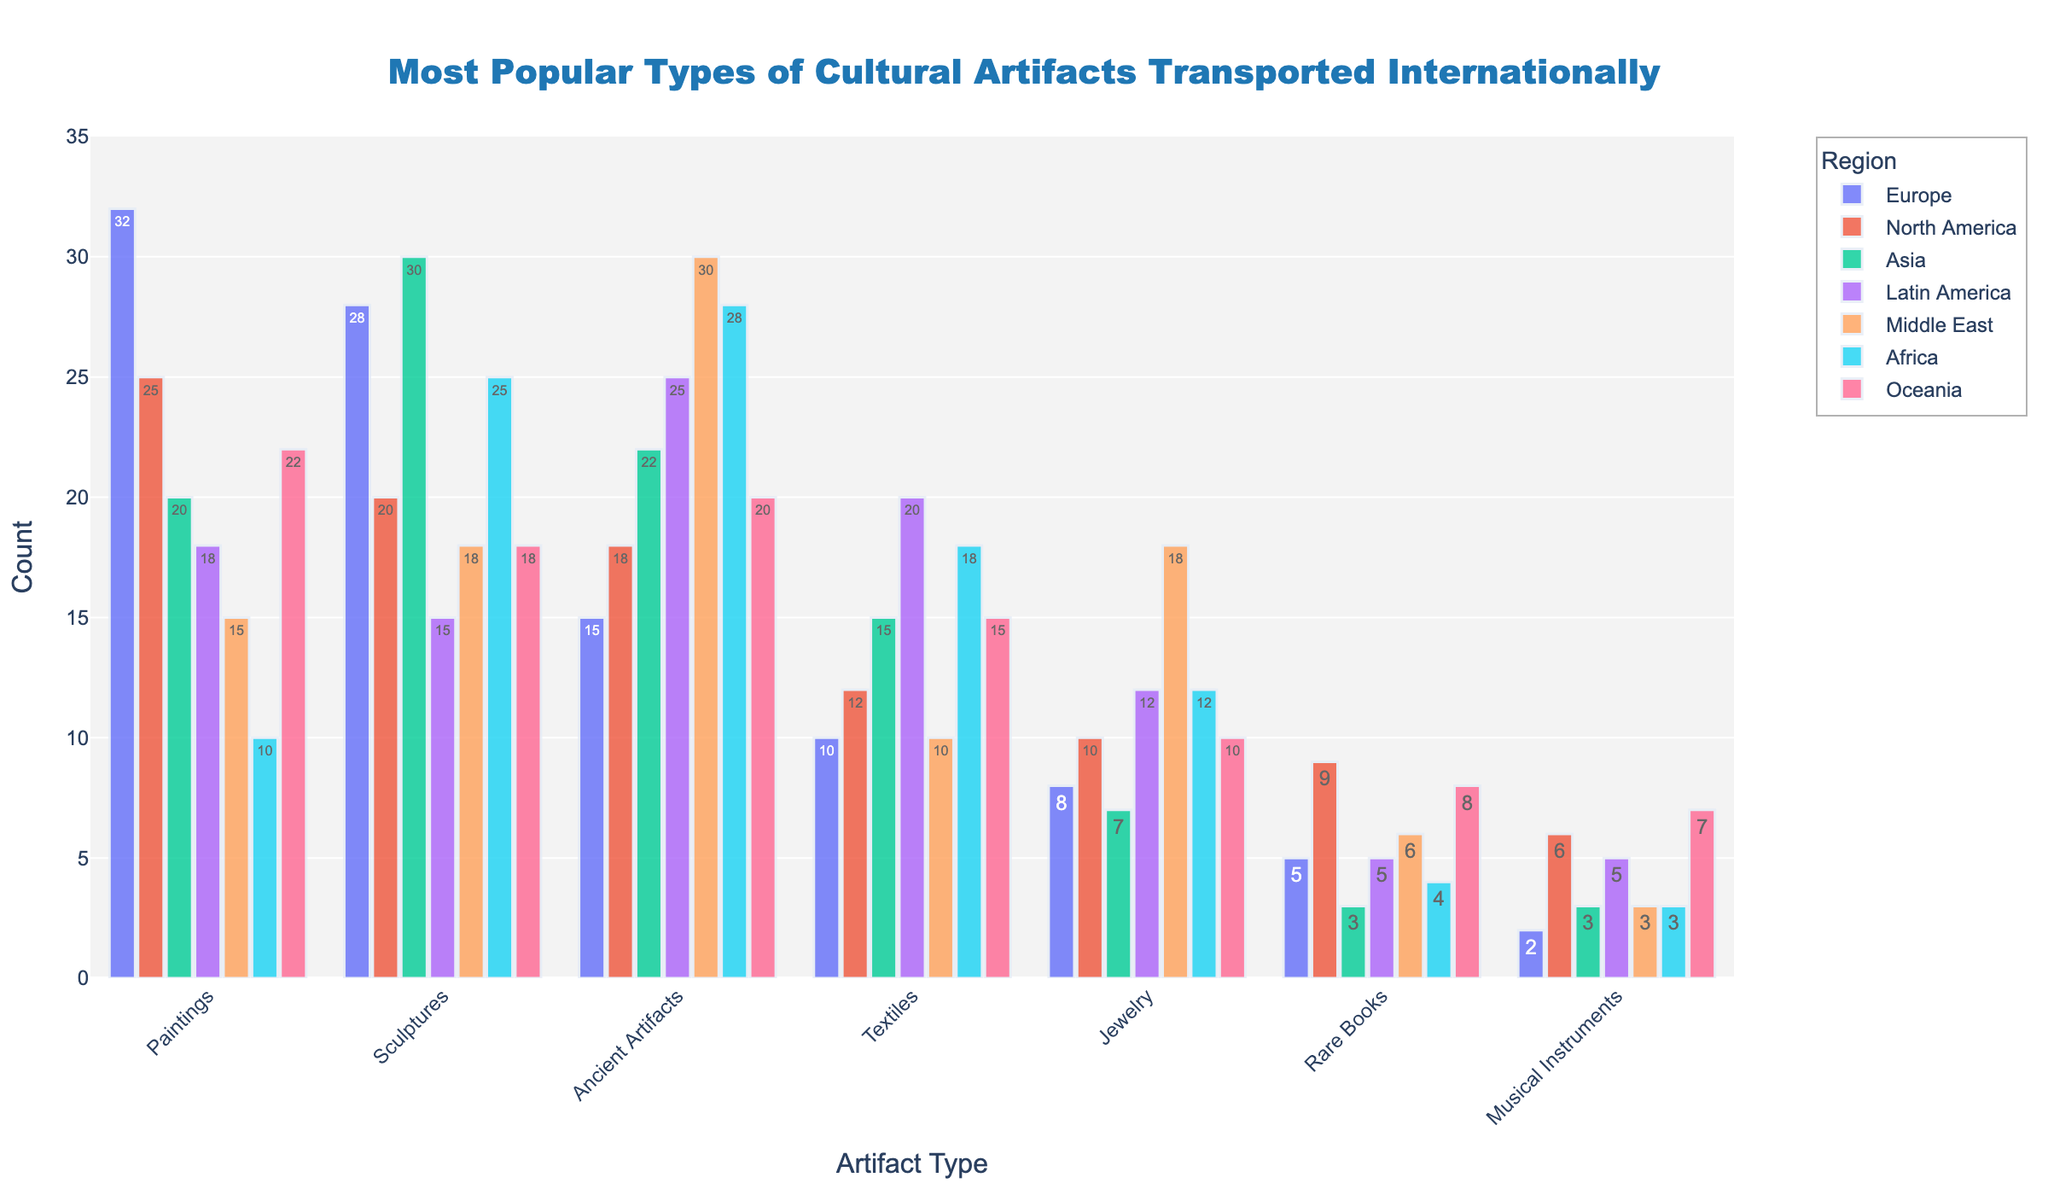Which region has the highest number of sculptures transported? The bar representing Asia for Sculptures is the tallest among all regions.
Answer: Asia What is the difference in the number of paintings transported between Europe and North America? Europe transported 32 paintings, and North America transported 25. The difference is 32 - 25.
Answer: 7 Which artifact type is most popular in the Middle East? The tallest bar for the Middle East is Ancient Artifacts.
Answer: Ancient Artifacts How many total types of artifacts were transported from Africa? Adding the counts for Africa: 10 (Paintings) + 25 (Sculptures) + 28 (Ancient Artifacts) + 18 (Textiles) + 12 (Jewelry) + 4 (Rare Books) + 3 (Musical Instruments) = 100.
Answer: 100 Which region has the least number of musical instruments transported? Europe has the shortest bar for Musical Instruments with 2.
Answer: Europe Is the number of rare books transported from Oceania greater than from the Middle East? Oceania transported 8 rare books, while the Middle East transported 6. 8 is greater than 6.
Answer: Yes How many more ancient artifacts does Asia transport compared to Europe? Asia transported 22 Ancient Artifacts, and Europe transported 15. The difference is 22 - 15.
Answer: 7 What is the average number of transported textiles across all regions? To find the average, sum the counts for Textiles: 10 (Europe) + 12 (North America) + 15 (Asia) + 20 (Latin America) + 10 (Middle East) + 18 (Africa) + 15 (Oceania) = 100. Then divide by the number of regions (7). 100 / 7.
Answer: ~14.3 Which region has a higher count for jewelry, Latin America or North America? Latin America has 12 Jewelry, while North America has 10. 12 is greater than 10.
Answer: Latin America Which two artifact types have the equal highest count for a single region, and what is the count? Sculptures in Asia and Ancient Artifacts in the Middle East both have the highest single count of 30.
Answer: Sculptures and Ancient Artifacts, 30 